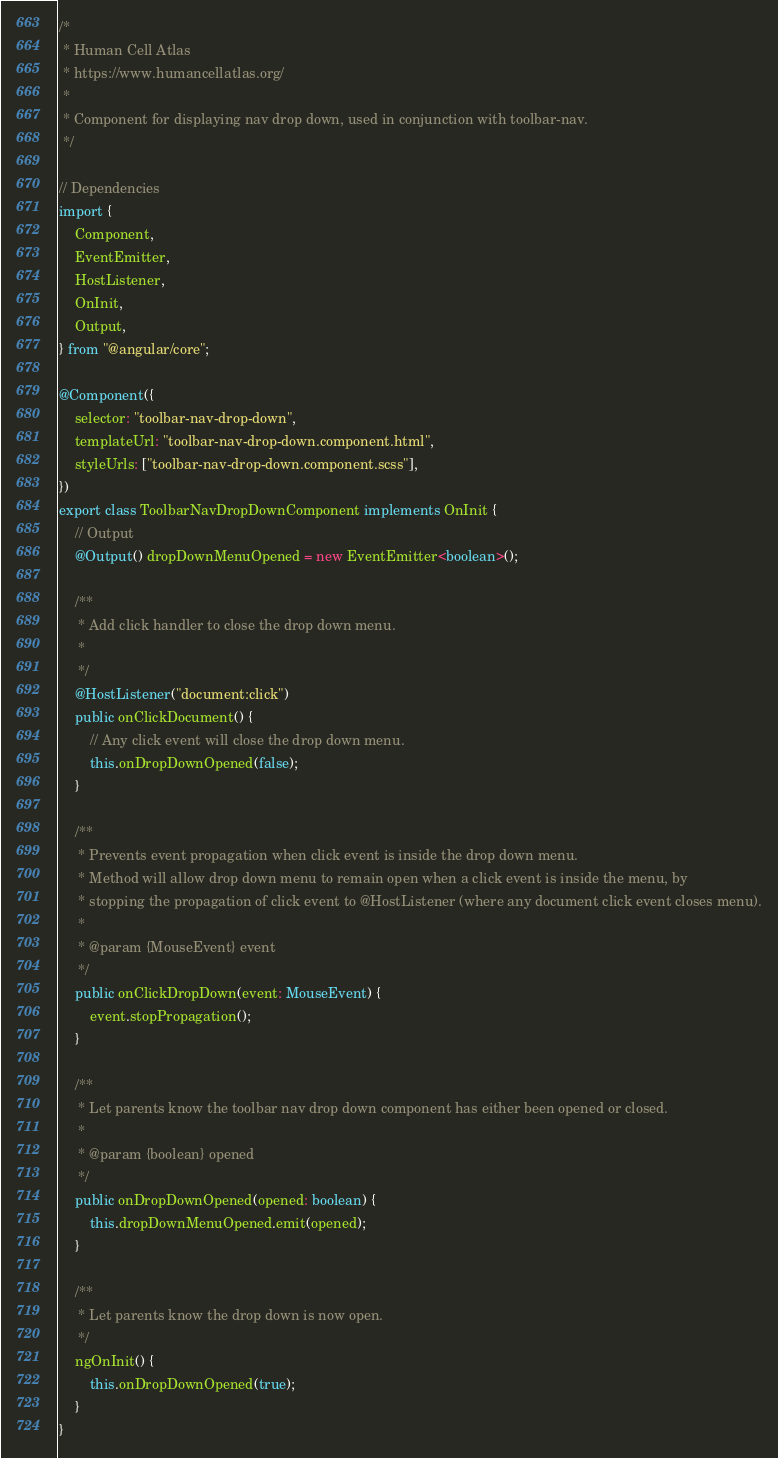Convert code to text. <code><loc_0><loc_0><loc_500><loc_500><_TypeScript_>/*
 * Human Cell Atlas
 * https://www.humancellatlas.org/
 *
 * Component for displaying nav drop down, used in conjunction with toolbar-nav.
 */

// Dependencies
import {
    Component,
    EventEmitter,
    HostListener,
    OnInit,
    Output,
} from "@angular/core";

@Component({
    selector: "toolbar-nav-drop-down",
    templateUrl: "toolbar-nav-drop-down.component.html",
    styleUrls: ["toolbar-nav-drop-down.component.scss"],
})
export class ToolbarNavDropDownComponent implements OnInit {
    // Output
    @Output() dropDownMenuOpened = new EventEmitter<boolean>();

    /**
     * Add click handler to close the drop down menu.
     *
     */
    @HostListener("document:click")
    public onClickDocument() {
        // Any click event will close the drop down menu.
        this.onDropDownOpened(false);
    }

    /**
     * Prevents event propagation when click event is inside the drop down menu.
     * Method will allow drop down menu to remain open when a click event is inside the menu, by
     * stopping the propagation of click event to @HostListener (where any document click event closes menu).
     *
     * @param {MouseEvent} event
     */
    public onClickDropDown(event: MouseEvent) {
        event.stopPropagation();
    }

    /**
     * Let parents know the toolbar nav drop down component has either been opened or closed.
     *
     * @param {boolean} opened
     */
    public onDropDownOpened(opened: boolean) {
        this.dropDownMenuOpened.emit(opened);
    }

    /**
     * Let parents know the drop down is now open.
     */
    ngOnInit() {
        this.onDropDownOpened(true);
    }
}
</code> 